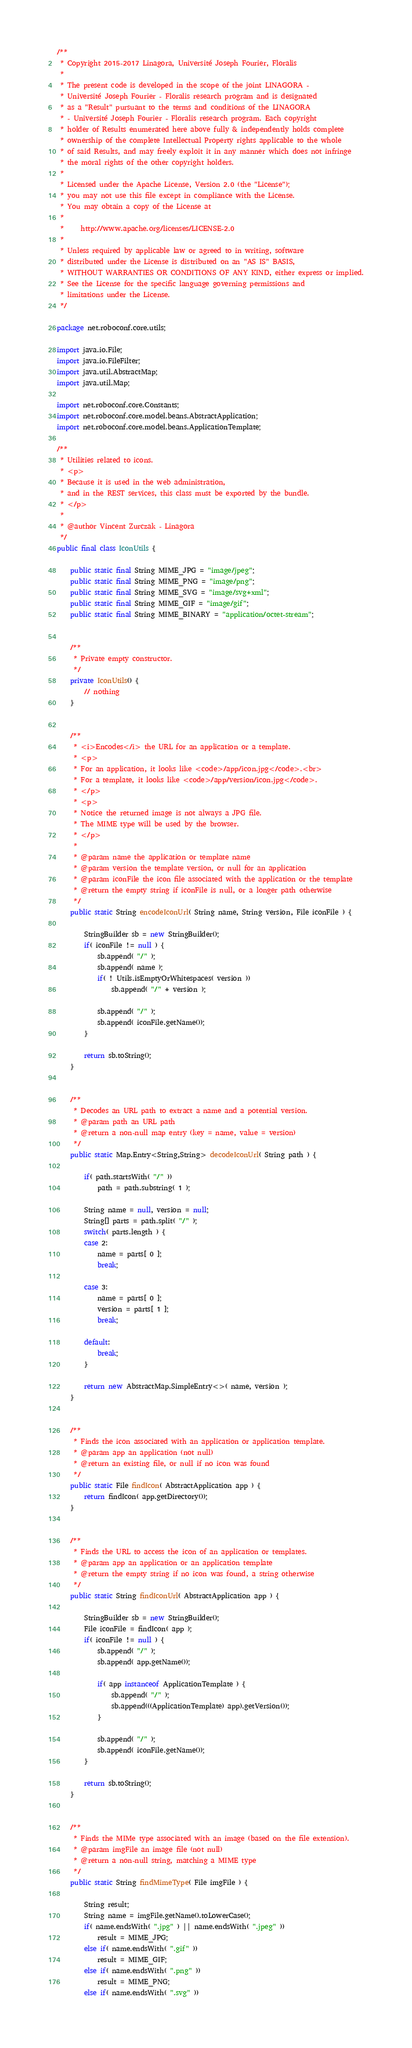<code> <loc_0><loc_0><loc_500><loc_500><_Java_>/**
 * Copyright 2015-2017 Linagora, Université Joseph Fourier, Floralis
 *
 * The present code is developed in the scope of the joint LINAGORA -
 * Université Joseph Fourier - Floralis research program and is designated
 * as a "Result" pursuant to the terms and conditions of the LINAGORA
 * - Université Joseph Fourier - Floralis research program. Each copyright
 * holder of Results enumerated here above fully & independently holds complete
 * ownership of the complete Intellectual Property rights applicable to the whole
 * of said Results, and may freely exploit it in any manner which does not infringe
 * the moral rights of the other copyright holders.
 *
 * Licensed under the Apache License, Version 2.0 (the "License");
 * you may not use this file except in compliance with the License.
 * You may obtain a copy of the License at
 *
 *     http://www.apache.org/licenses/LICENSE-2.0
 *
 * Unless required by applicable law or agreed to in writing, software
 * distributed under the License is distributed on an "AS IS" BASIS,
 * WITHOUT WARRANTIES OR CONDITIONS OF ANY KIND, either express or implied.
 * See the License for the specific language governing permissions and
 * limitations under the License.
 */

package net.roboconf.core.utils;

import java.io.File;
import java.io.FileFilter;
import java.util.AbstractMap;
import java.util.Map;

import net.roboconf.core.Constants;
import net.roboconf.core.model.beans.AbstractApplication;
import net.roboconf.core.model.beans.ApplicationTemplate;

/**
 * Utilities related to icons.
 * <p>
 * Because it is used in the web administration,
 * and in the REST services, this class must be exported by the bundle.
 * </p>
 *
 * @author Vincent Zurczak - Linagora
 */
public final class IconUtils {

	public static final String MIME_JPG = "image/jpeg";
	public static final String MIME_PNG = "image/png";
	public static final String MIME_SVG = "image/svg+xml";
	public static final String MIME_GIF = "image/gif";
	public static final String MIME_BINARY = "application/octet-stream";


	/**
	 * Private empty constructor.
	 */
	private IconUtils() {
		// nothing
	}


	/**
	 * <i>Encodes</i> the URL for an application or a template.
	 * <p>
	 * For an application, it looks like <code>/app/icon.jpg</code>.<br>
	 * For a template, it looks like <code>/app/version/icon.jpg</code>.
	 * </p>
	 * <p>
	 * Notice the returned image is not always a JPG file.
	 * The MIME type will be used by the browser.
	 * </p>
	 *
	 * @param name the application or template name
	 * @param version the template version, or null for an application
	 * @param iconFile the icon file associated with the application or the template
	 * @return the empty string if iconFile is null, or a longer path otherwise
	 */
	public static String encodeIconUrl( String name, String version, File iconFile ) {

		StringBuilder sb = new StringBuilder();
		if( iconFile != null ) {
			sb.append( "/" );
			sb.append( name );
			if( ! Utils.isEmptyOrWhitespaces( version ))
				sb.append( "/" + version );

			sb.append( "/" );
			sb.append( iconFile.getName());
		}

		return sb.toString();
	}


	/**
	 * Decodes an URL path to extract a name and a potential version.
	 * @param path an URL path
	 * @return a non-null map entry (key = name, value = version)
	 */
	public static Map.Entry<String,String> decodeIconUrl( String path ) {

		if( path.startsWith( "/" ))
			path = path.substring( 1 );

		String name = null, version = null;
		String[] parts = path.split( "/" );
		switch( parts.length ) {
		case 2:
			name = parts[ 0 ];
			break;

		case 3:
			name = parts[ 0 ];
			version = parts[ 1 ];
			break;

		default:
			break;
		}

		return new AbstractMap.SimpleEntry<>( name, version );
	}


	/**
	 * Finds the icon associated with an application or application template.
	 * @param app an application (not null)
	 * @return an existing file, or null if no icon was found
	 */
	public static File findIcon( AbstractApplication app ) {
		return findIcon( app.getDirectory());
	}


	/**
	 * Finds the URL to access the icon of an application or templates.
	 * @param app an application or an application template
	 * @return the empty string if no icon was found, a string otherwise
	 */
	public static String findIconUrl( AbstractApplication app ) {

		StringBuilder sb = new StringBuilder();
		File iconFile = findIcon( app );
		if( iconFile != null ) {
			sb.append( "/" );
			sb.append( app.getName());

			if( app instanceof ApplicationTemplate ) {
				sb.append( "/" );
				sb.append(((ApplicationTemplate) app).getVersion());
			}

			sb.append( "/" );
			sb.append( iconFile.getName());
		}

		return sb.toString();
	}


	/**
	 * Finds the MIMe type associated with an image (based on the file extension).
	 * @param imgFile an image file (not null)
	 * @return a non-null string, matching a MIME type
	 */
	public static String findMimeType( File imgFile ) {

		String result;
		String name = imgFile.getName().toLowerCase();
		if( name.endsWith( ".jpg" ) || name.endsWith( ".jpeg" ))
			result = MIME_JPG;
		else if( name.endsWith( ".gif" ))
			result = MIME_GIF;
		else if( name.endsWith( ".png" ))
			result = MIME_PNG;
		else if( name.endsWith( ".svg" ))</code> 